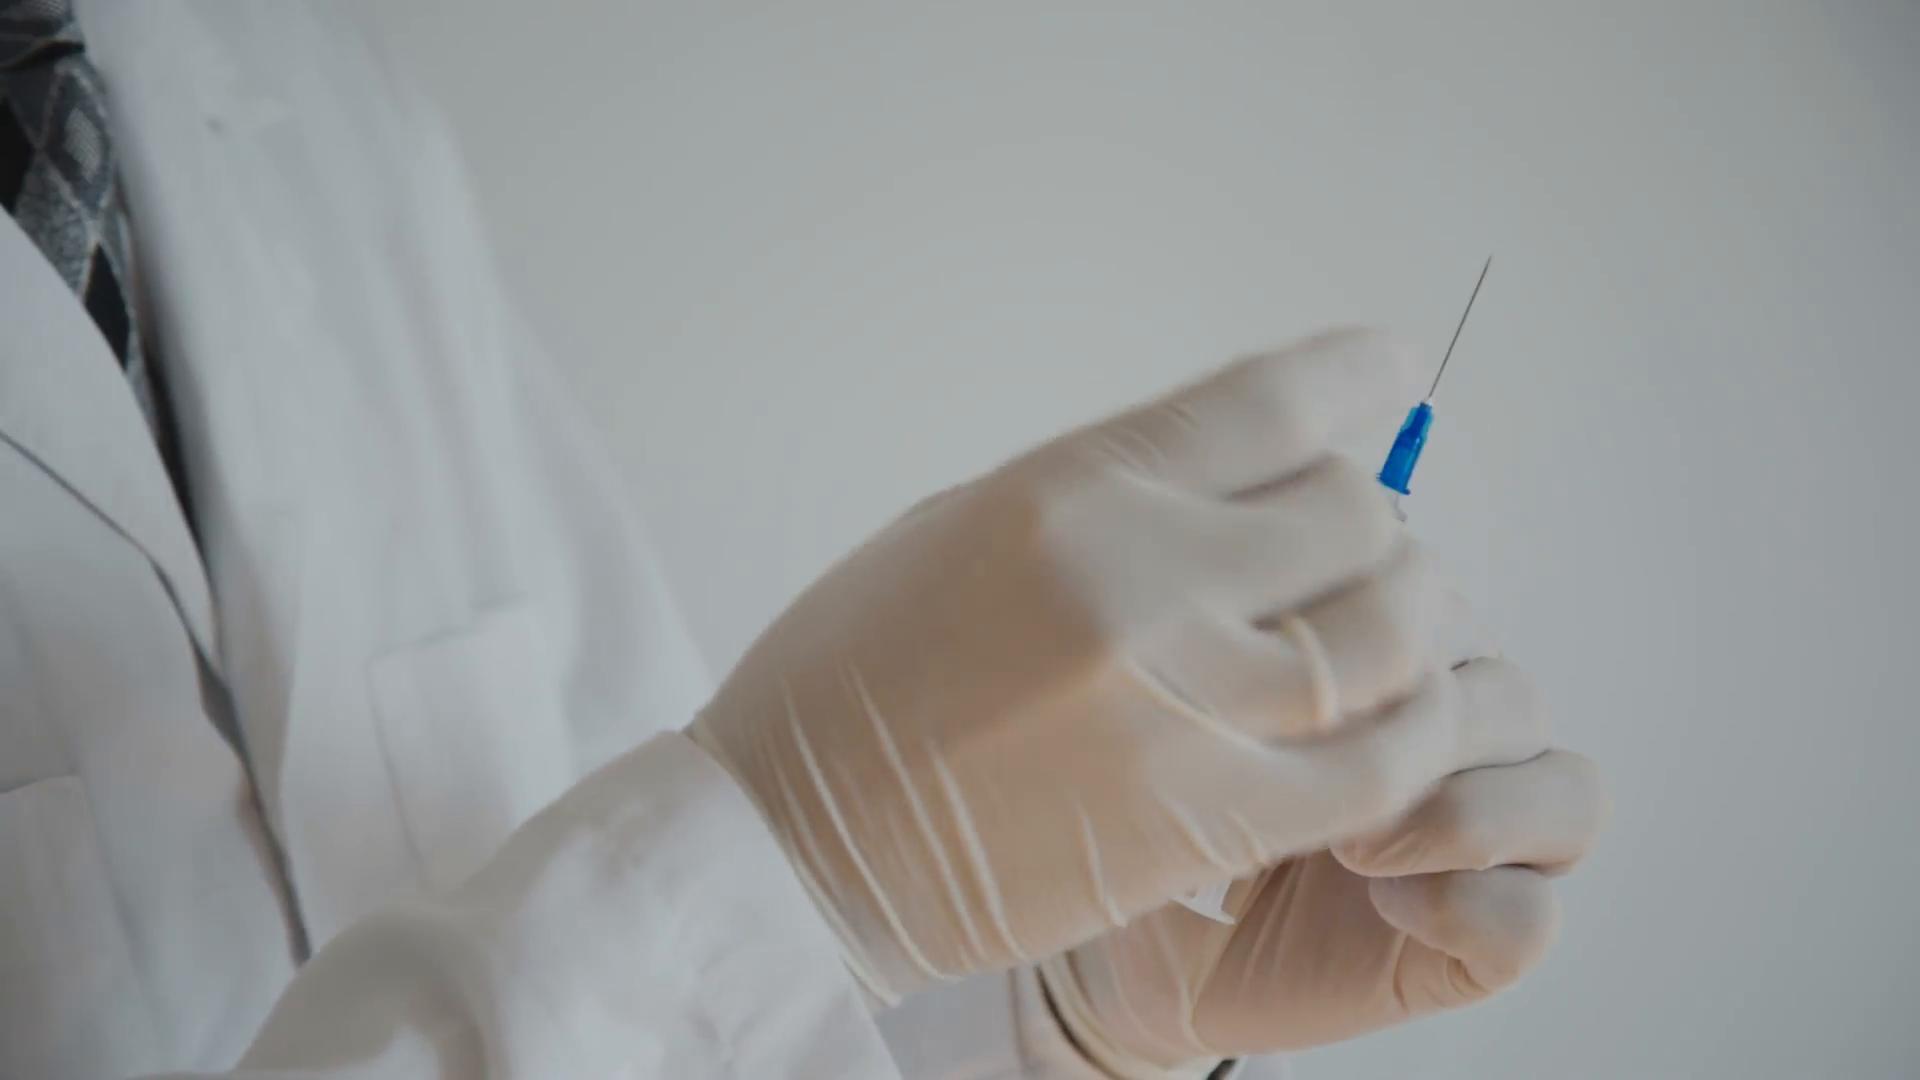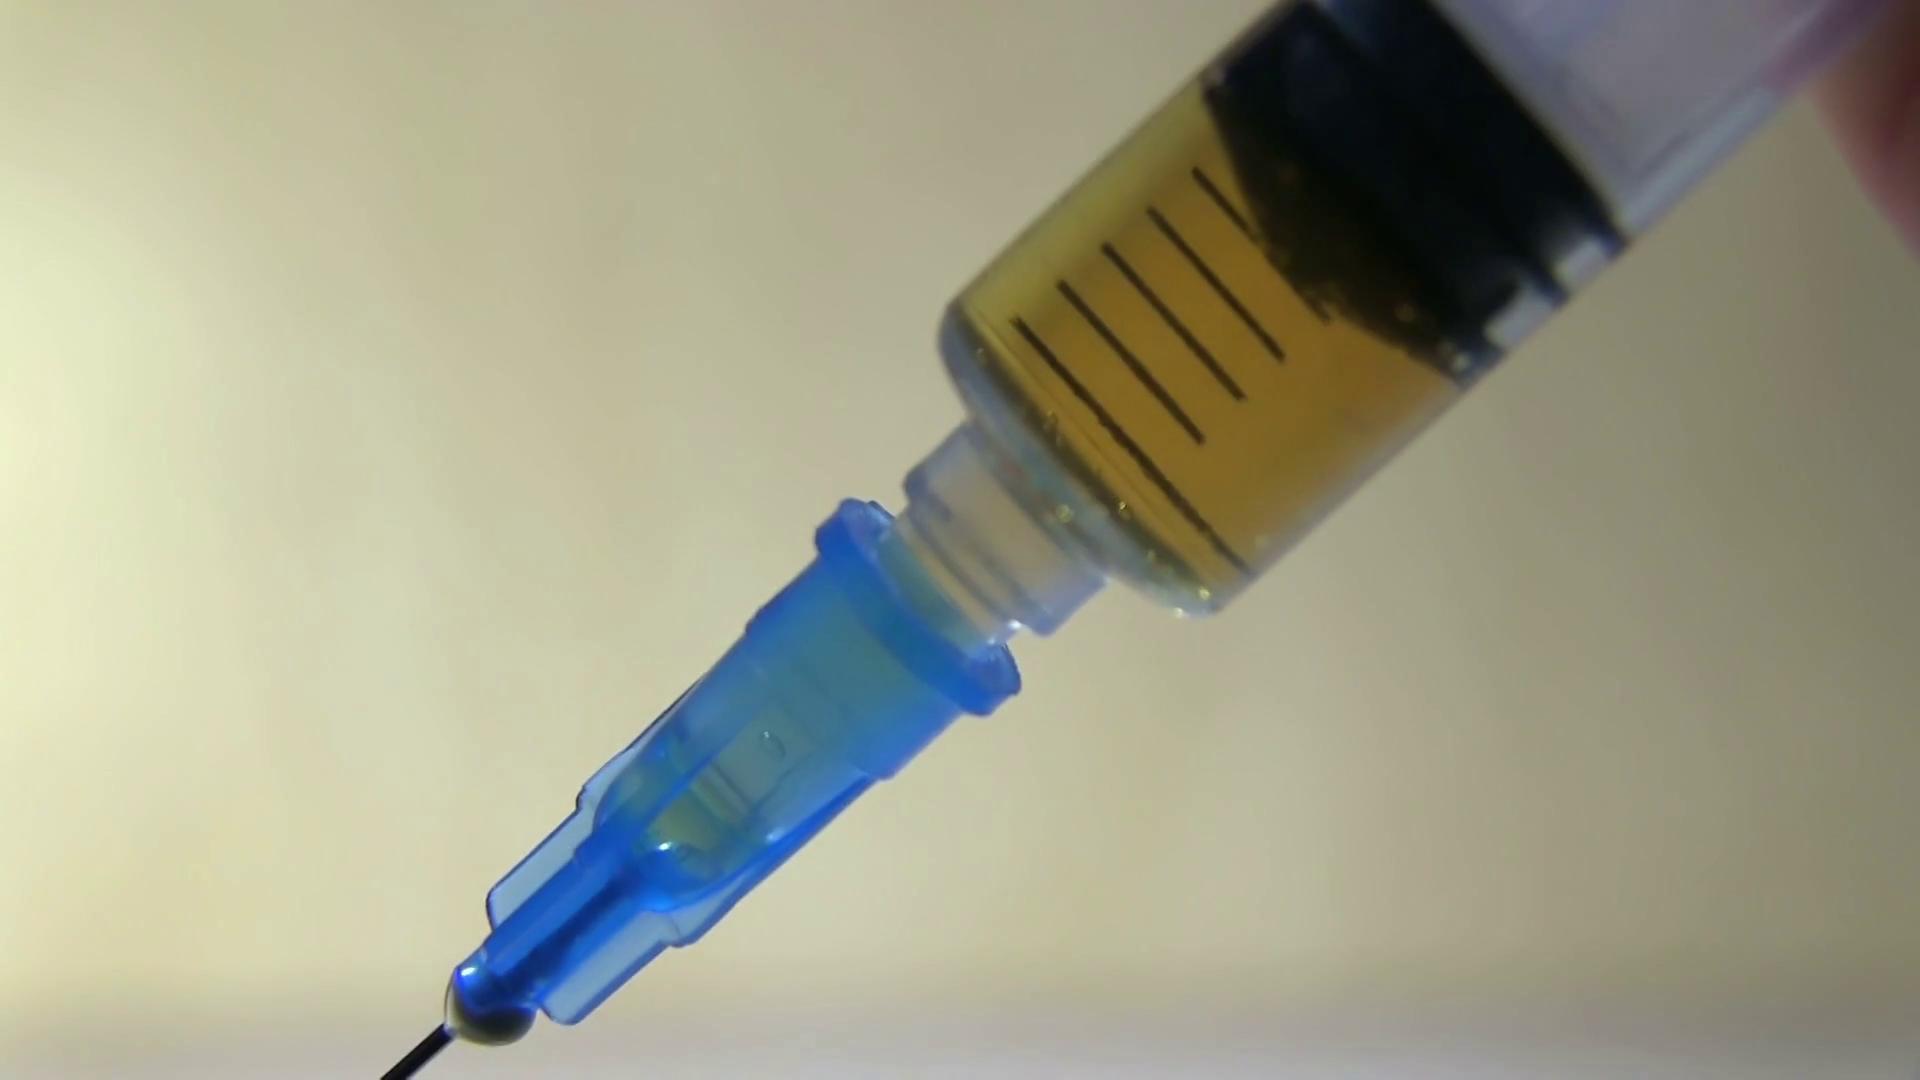The first image is the image on the left, the second image is the image on the right. Given the left and right images, does the statement "There are two needles with at least two blue gloves." hold true? Answer yes or no. No. The first image is the image on the left, the second image is the image on the right. Analyze the images presented: Is the assertion "Both syringes are pointed upwards." valid? Answer yes or no. No. 